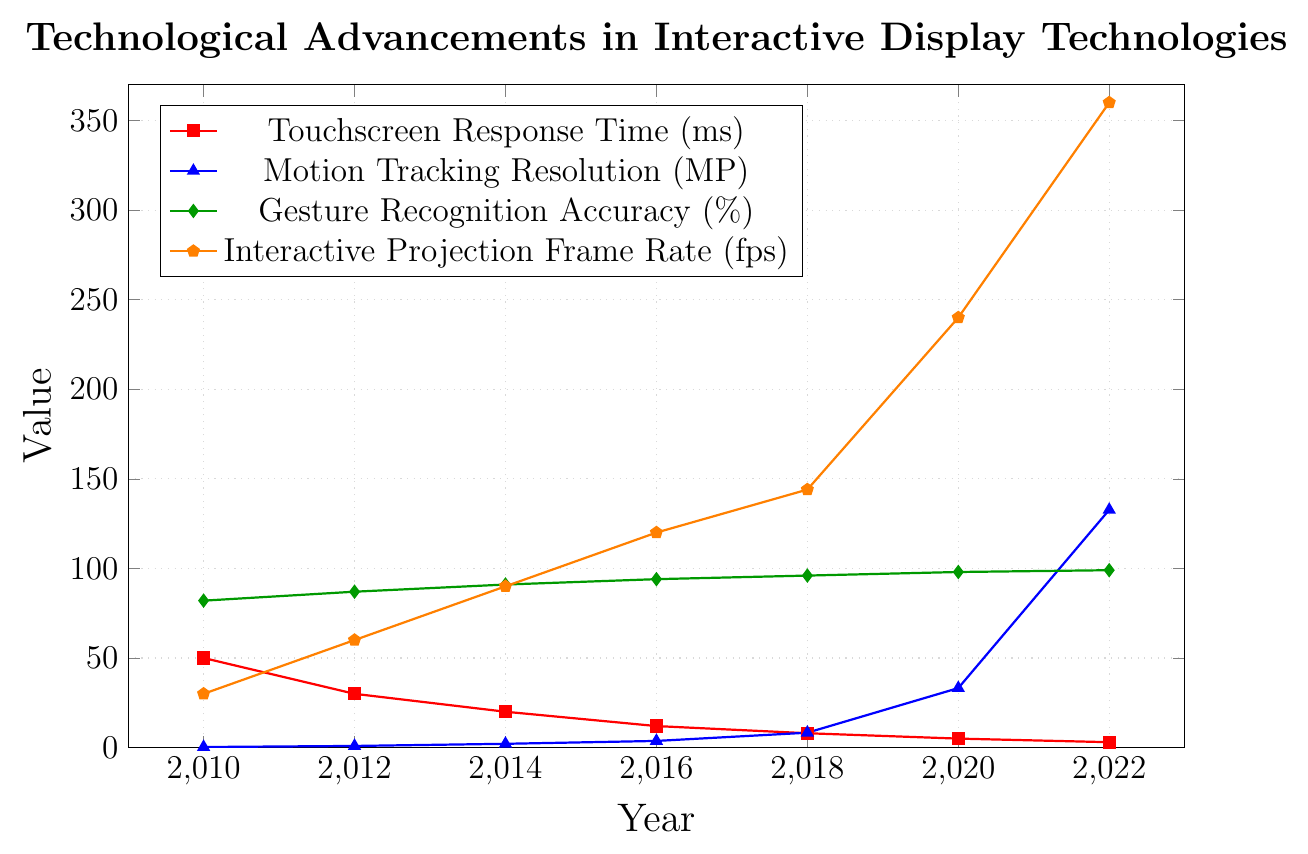What trend do you observe in Touchscreen Response Time from 2010 to 2022? The Touchscreen Response Time shows a decreasing trend. Starting from 50 ms in 2010, it consistently goes down to 3 ms by 2022.
Answer: Decreasing trend Which year had the largest improvement in Gesture Recognition Accuracy compared to the previous year? To determine this, calculate the difference in accuracy for each year compared to the previous year: 2012-2010: 87-82=5, 2014-2012: 91-87=4, 2016-2014: 94-91=3, 2018-2016: 96-94=2, 2020-2018: 98-96=2, 2022-2020: 99-98=1. The largest improvement was in 2010-2012 with a 5% increase.
Answer: 2012 How much did the Interactive Projection Frame Rate increase from 2010 to 2022? Subtract the 2010 frame rate from the 2022 frame rate: 360 fps - 30 fps = 330 fps.
Answer: 330 fps Compare the Motion Tracking Resolution in 2010 and 2020. How many times higher is it in 2020 compared to 2010? First, convert the resolutions to megapixels: 2010 = 0.3 MP, 2020 = 33.2 MP. Then, divide the 2020 value by the 2010 value: 33.2 / 0.3 = 110.67 times.
Answer: 110.67 times In which year did the Interactive Projection Frame Rate first exceed 100 fps? Examine the values for each year and identify the year when the frame rate first exceeds 100 fps. It surpasses 100 fps in 2016 with 120 fps.
Answer: 2016 Which metric showed the most significant improvement from 2012 to 2014? Find the difference for each metric between 2012 and 2014: Touchscreen Response Time: 30-20=10 ms, Motion Tracking Resolution: 2.1-0.9=1.2 MP, Gesture Recognition Accuracy: 91-87=4%, Interactive Projection Frame Rate: 90-60=30 fps. The most significant improvement is in the Interactive Projection Frame Rate.
Answer: Interactive Projection Frame Rate What was the Gesture Recognition Accuracy in 2016, and how did it change by 2022? The Gesture Recognition Accuracy in 2016 was 94%. By 2022, it increased to 99%. The change is 99% - 94% = 5%.
Answer: Increased by 5% How did the Motion Tracking Resolution change from 2018 to 2022? Convert the resolutions to megapixels: 2018 = 8.3 MP, 2022 = 132.7 MP. Calculate the difference: 132.7 - 8.3 = 124.4 MP.
Answer: Increased by 124.4 MP 